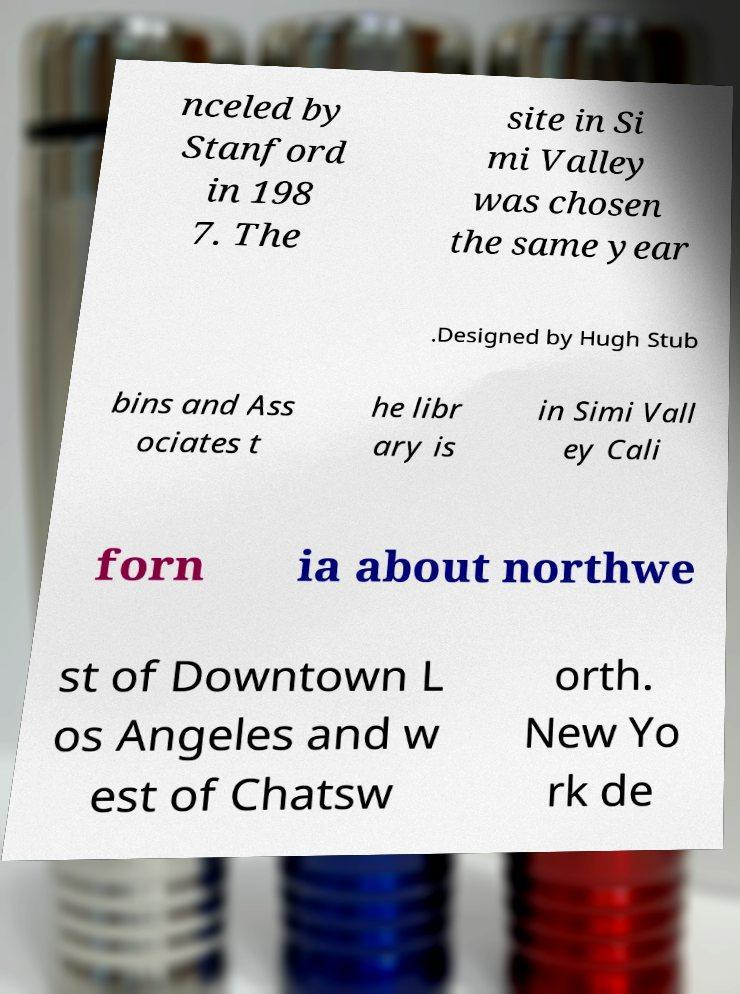I need the written content from this picture converted into text. Can you do that? nceled by Stanford in 198 7. The site in Si mi Valley was chosen the same year .Designed by Hugh Stub bins and Ass ociates t he libr ary is in Simi Vall ey Cali forn ia about northwe st of Downtown L os Angeles and w est of Chatsw orth. New Yo rk de 